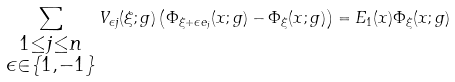<formula> <loc_0><loc_0><loc_500><loc_500>\sum _ { \substack { 1 \leq j \leq n \\ \epsilon \in \{ 1 , - 1 \} } } V _ { \epsilon j } ( \xi ; g ) \left ( \Phi _ { \xi + \epsilon e _ { j } } ( x ; g ) - \Phi _ { \xi } ( x ; g ) \right ) = E _ { 1 } ( x ) \Phi _ { \xi } ( x ; g )</formula> 